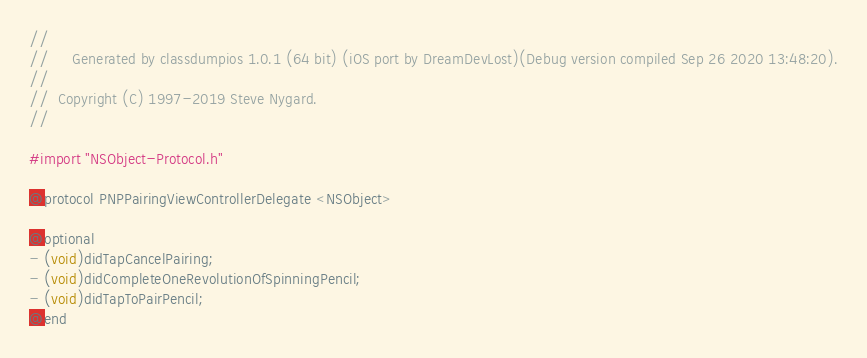Convert code to text. <code><loc_0><loc_0><loc_500><loc_500><_C_>//
//     Generated by classdumpios 1.0.1 (64 bit) (iOS port by DreamDevLost)(Debug version compiled Sep 26 2020 13:48:20).
//
//  Copyright (C) 1997-2019 Steve Nygard.
//

#import "NSObject-Protocol.h"

@protocol PNPPairingViewControllerDelegate <NSObject>

@optional
- (void)didTapCancelPairing;
- (void)didCompleteOneRevolutionOfSpinningPencil;
- (void)didTapToPairPencil;
@end

</code> 